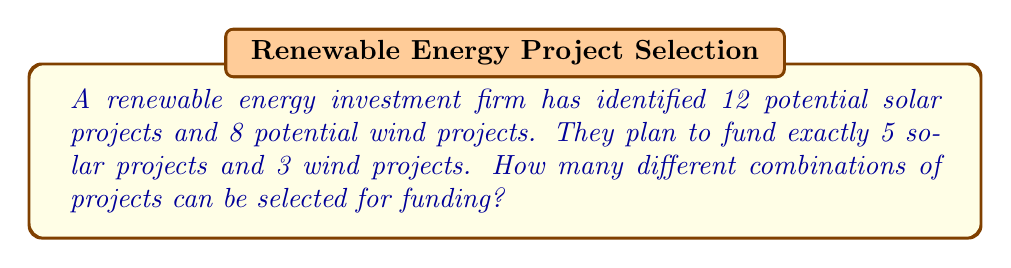Can you solve this math problem? Let's approach this step-by-step:

1) We need to select 5 solar projects out of 12 and 3 wind projects out of 8.

2) For the solar projects:
   - This is a combination problem, as the order doesn't matter.
   - We use the combination formula: $$C(n,r) = \frac{n!}{r!(n-r)!}$$
   - Here, $n = 12$ and $r = 5$
   - So, the number of ways to select solar projects is:
     $$C(12,5) = \frac{12!}{5!(12-5)!} = \frac{12!}{5!7!} = 792$$

3) For the wind projects:
   - Similarly, we use the combination formula
   - Here, $n = 8$ and $r = 3$
   - The number of ways to select wind projects is:
     $$C(8,3) = \frac{8!}{3!(8-3)!} = \frac{8!}{3!5!} = 56$$

4) By the Multiplication Principle, the total number of ways to select both solar and wind projects is:
   $$792 \times 56 = 44,352$$

Therefore, there are 44,352 different combinations of projects that can be selected for funding.
Answer: 44,352 